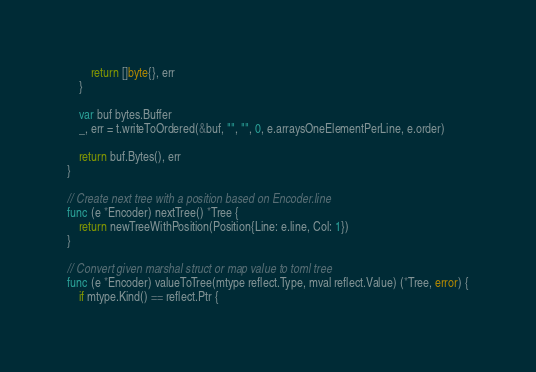Convert code to text. <code><loc_0><loc_0><loc_500><loc_500><_Go_>		return []byte{}, err
	}

	var buf bytes.Buffer
	_, err = t.writeToOrdered(&buf, "", "", 0, e.arraysOneElementPerLine, e.order)

	return buf.Bytes(), err
}

// Create next tree with a position based on Encoder.line
func (e *Encoder) nextTree() *Tree {
	return newTreeWithPosition(Position{Line: e.line, Col: 1})
}

// Convert given marshal struct or map value to toml tree
func (e *Encoder) valueToTree(mtype reflect.Type, mval reflect.Value) (*Tree, error) {
	if mtype.Kind() == reflect.Ptr {</code> 